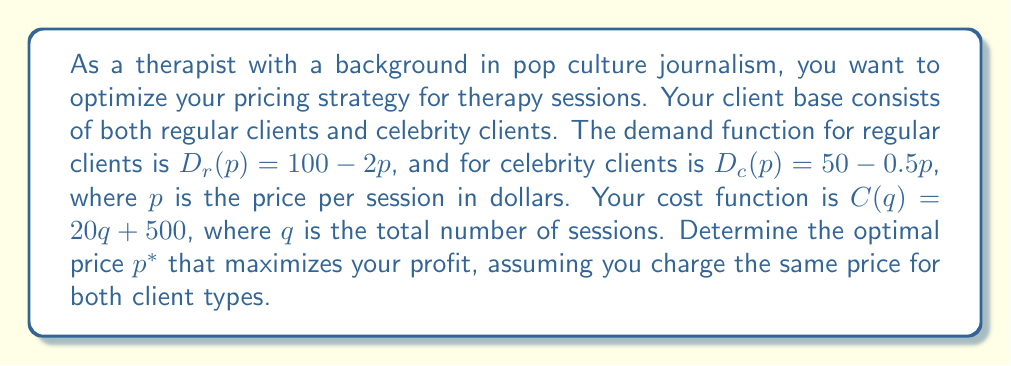Can you answer this question? Let's approach this step-by-step:

1) First, we need to formulate the total demand function:
   $D(p) = D_r(p) + D_c(p) = (100 - 2p) + (50 - 0.5p) = 150 - 2.5p$

2) The revenue function is price times quantity:
   $R(p) = p \cdot D(p) = p(150 - 2.5p) = 150p - 2.5p^2$

3) The cost function in terms of price is:
   $C(p) = 20D(p) + 500 = 20(150 - 2.5p) + 500 = 3000 - 50p + 500 = 3500 - 50p$

4) The profit function is revenue minus cost:
   $\Pi(p) = R(p) - C(p) = (150p - 2.5p^2) - (3500 - 50p)$
   $\Pi(p) = -2.5p^2 + 200p - 3500$

5) To maximize profit, we find where the derivative of the profit function equals zero:
   $\frac{d\Pi}{dp} = -5p + 200 = 0$

6) Solving this equation:
   $-5p + 200 = 0$
   $-5p = -200$
   $p = 40$

7) To confirm this is a maximum, we check the second derivative:
   $\frac{d^2\Pi}{dp^2} = -5 < 0$, confirming a maximum.

Therefore, the optimal price $p^*$ is $40 per session.
Answer: $p^* = $40 per session 